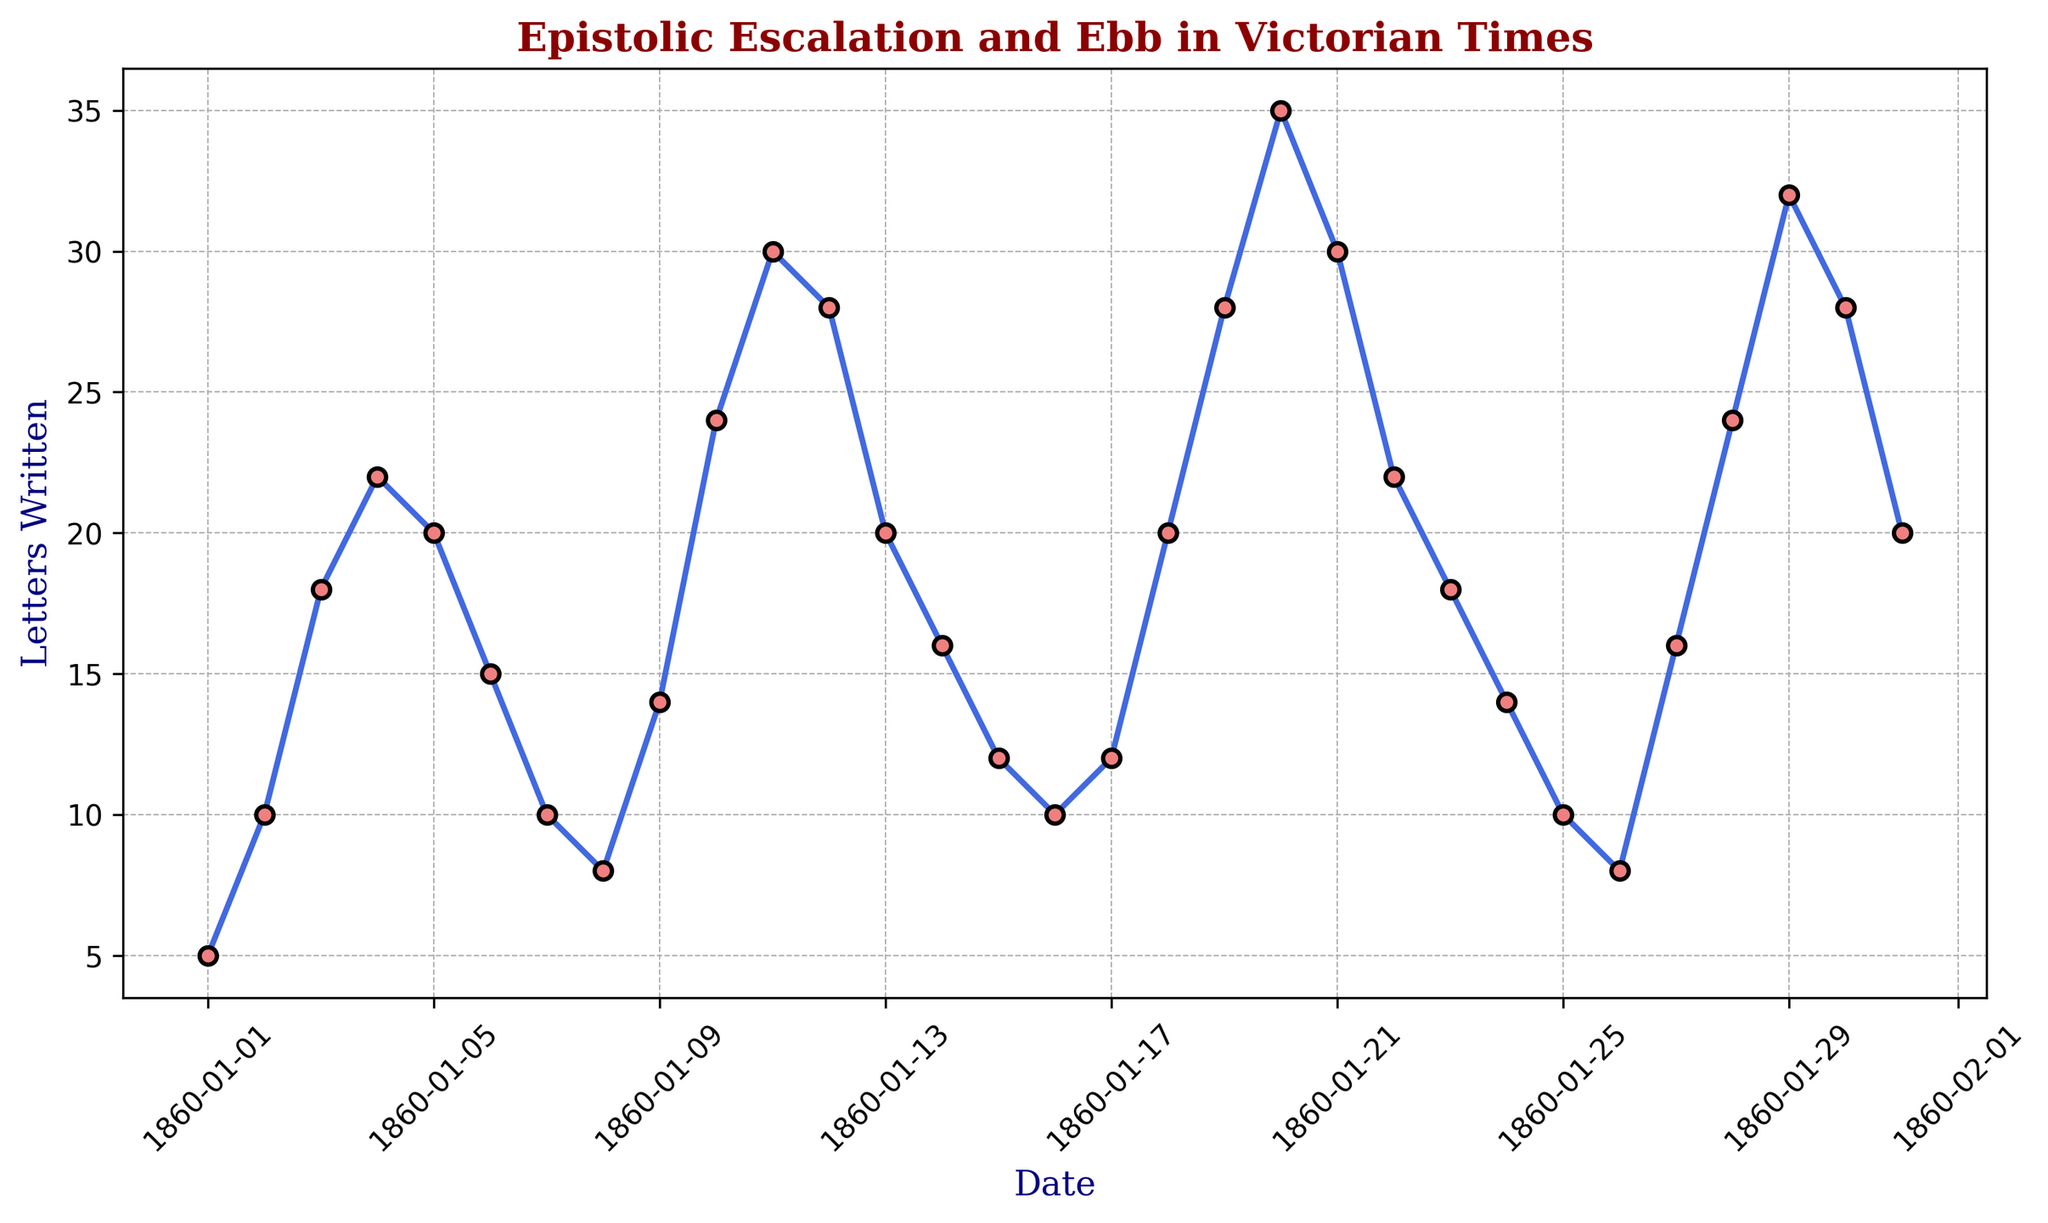What's the highest number of letters written on any single day? To find the highest number of letters written on any single day, look for the peak value on the plot. The highest point on the graph corresponds to the maximum number of letters written.
Answer: 35 Which date marks the first significant spike in letter-writing frequency? Identify the initial notable increase in the number of letters written by finding the first steep rise on the plot. The date at this rise represents the first significant spike.
Answer: 03-01-1860 Compare the number of letters written on 10-01-1860 and 20-01-1860. Which day had more letters written? Locate the points for 10-01-1860 and 20-01-1860 on the plot. Compare their corresponding values to determine which is higher.
Answer: 20-01-1860 What is the difference in letter-writing frequency between the peak and trough within the first ten days of January 1860? Identify the highest and lowest points on the graph within the first ten days. Calculate the difference by subtracting the lowest value from the highest value.
Answer: 19 How many days show a marked decrease in letters written after a notable peak? Examine the graph for multiple spikes followed by declines. Count the number of days when there is a clear drop after a significant rise in letter-writing frequency.
Answer: 3 What visual pattern characterizes the period between 16-01-1860 and 20-01-1860? Look at the section of the plot that covers the days from 16-01-1860 to 20-01-1860. Describe the trend observed in the number of letters written during this period.
Answer: Rising trend What was the total number of letters written on 04-01-1860, 11-01-1860, and 18-01-1860 combined? Locate the values for each of these dates and sum them. The sum of 22 (04-01-1860), 30 (11-01-1860), and 20 (18-01-1860) will give the total.
Answer: 72 Which segment of the month shows the most stable frequency of letter writing, and how is this visualized? Identify the part of the plot where fluctuations are minimal. This stability is visualized by relatively flat or gently sloping lines. Check the graph for such a period.
Answer: 24-01-1860 to 27-01-1860 What is the average number of letters written during the days with the highest and lowest number of letters in January 1860? First, identify the highest and lowest numbers of letters written in January 1860, which are 35 and 5 respectively. Calculate the average of these two values.
Answer: 20 On which date do we see the deepest decline immediately after a peak in letter-writing frequency? Find the day where a sharp drop follows a preceding peak. Look at the steepest descent after a high point to determine the correct date.
Answer: 20-01-1860 